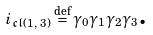<formula> <loc_0><loc_0><loc_500><loc_500>i _ { \mathfrak { c l } ( 1 \text {, } 3 ) } \overset { \text {def} } { = } \gamma _ { 0 } \gamma _ { 1 } \gamma _ { 2 } \gamma _ { 3 } \text {.}</formula> 